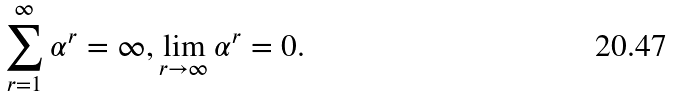Convert formula to latex. <formula><loc_0><loc_0><loc_500><loc_500>\sum _ { r = 1 } ^ { \infty } \alpha ^ { r } = \infty , \lim _ { r \to \infty } \alpha ^ { r } = 0 .</formula> 